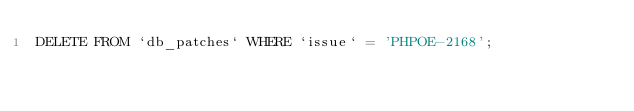Convert code to text. <code><loc_0><loc_0><loc_500><loc_500><_SQL_>DELETE FROM `db_patches` WHERE `issue` = 'PHPOE-2168';</code> 